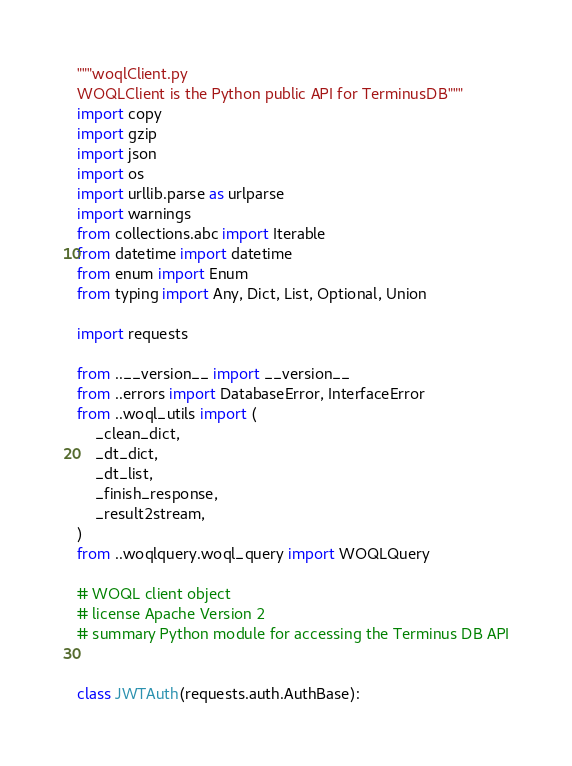Convert code to text. <code><loc_0><loc_0><loc_500><loc_500><_Python_>"""woqlClient.py
WOQLClient is the Python public API for TerminusDB"""
import copy
import gzip
import json
import os
import urllib.parse as urlparse
import warnings
from collections.abc import Iterable
from datetime import datetime
from enum import Enum
from typing import Any, Dict, List, Optional, Union

import requests

from ..__version__ import __version__
from ..errors import DatabaseError, InterfaceError
from ..woql_utils import (
    _clean_dict,
    _dt_dict,
    _dt_list,
    _finish_response,
    _result2stream,
)
from ..woqlquery.woql_query import WOQLQuery

# WOQL client object
# license Apache Version 2
# summary Python module for accessing the Terminus DB API


class JWTAuth(requests.auth.AuthBase):</code> 